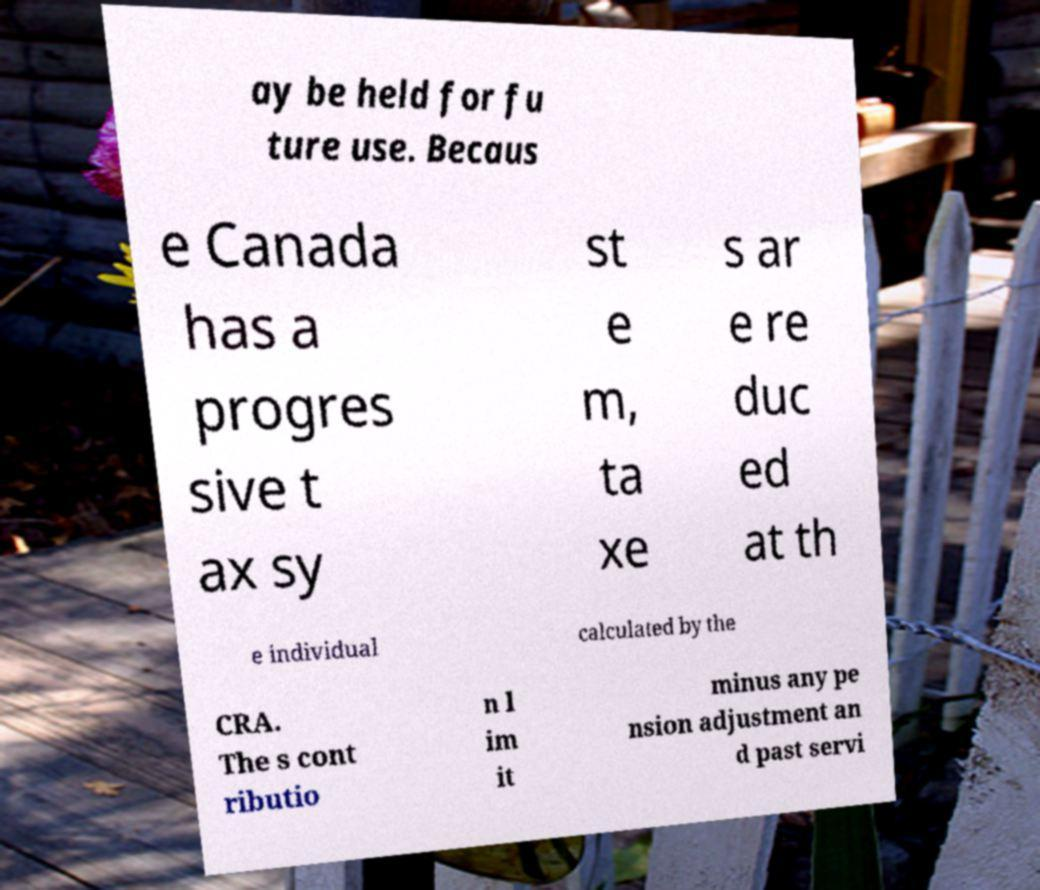Can you accurately transcribe the text from the provided image for me? ay be held for fu ture use. Becaus e Canada has a progres sive t ax sy st e m, ta xe s ar e re duc ed at th e individual calculated by the CRA. The s cont ributio n l im it minus any pe nsion adjustment an d past servi 